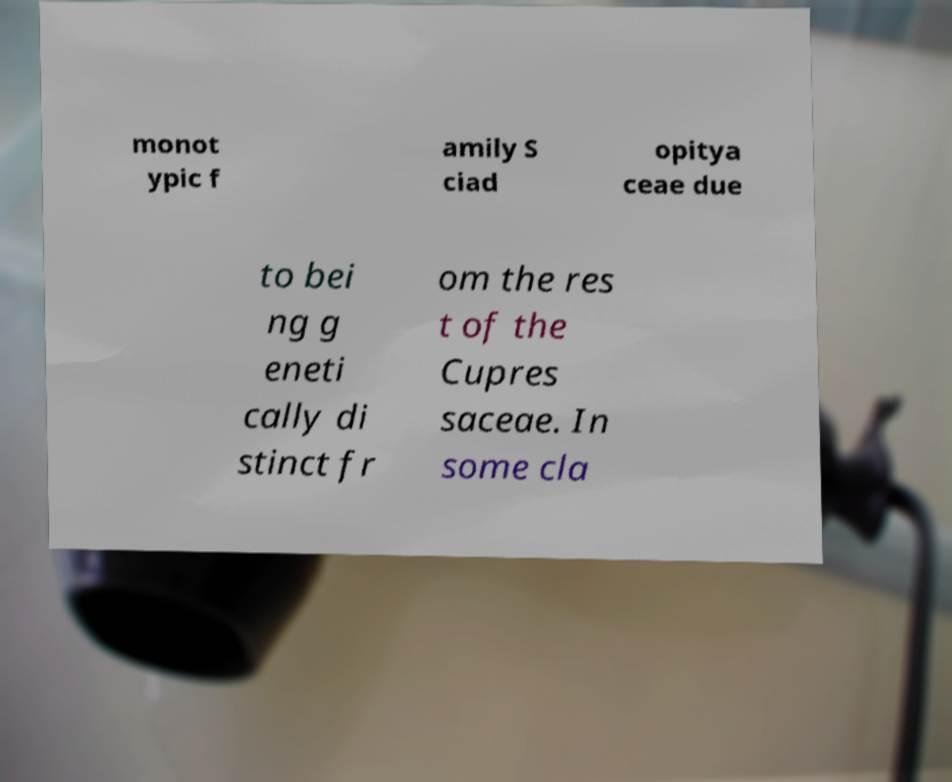Please identify and transcribe the text found in this image. monot ypic f amily S ciad opitya ceae due to bei ng g eneti cally di stinct fr om the res t of the Cupres saceae. In some cla 